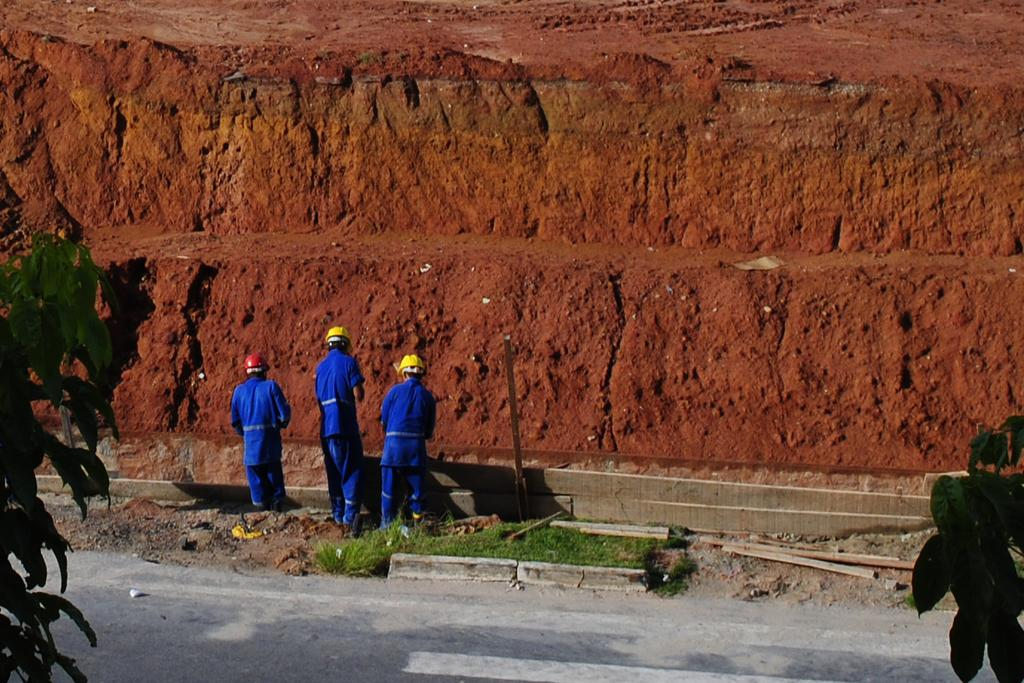How many people are in the image? There are three persons in the image. What are the persons wearing? The persons are wearing blue dresses. What type of natural elements can be seen in the image? There are trees in the image. What can be seen in the background of the image? There is a red mud dune in the background of the image. Which person has the longest tail in the image? There are no tails present on the persons in the image, as they are wearing dresses. 